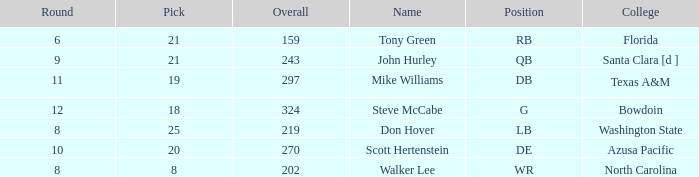How many overalls have a pick greater than 19, with florida as the college? 159.0. 